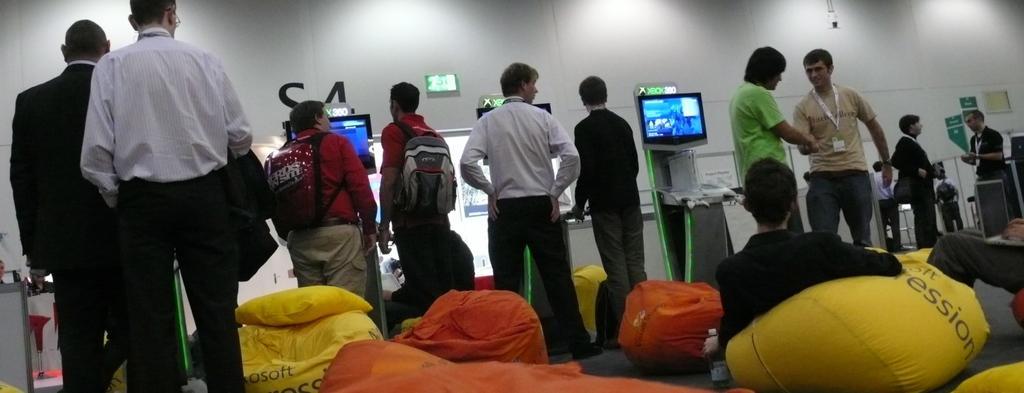Can you describe this image briefly? In the picture I can see there are groups of persons are standing. At the bottom of the picture I can see bean bags. In the background, I can see TV screens. On the right of the picture I can see two persons are talking 